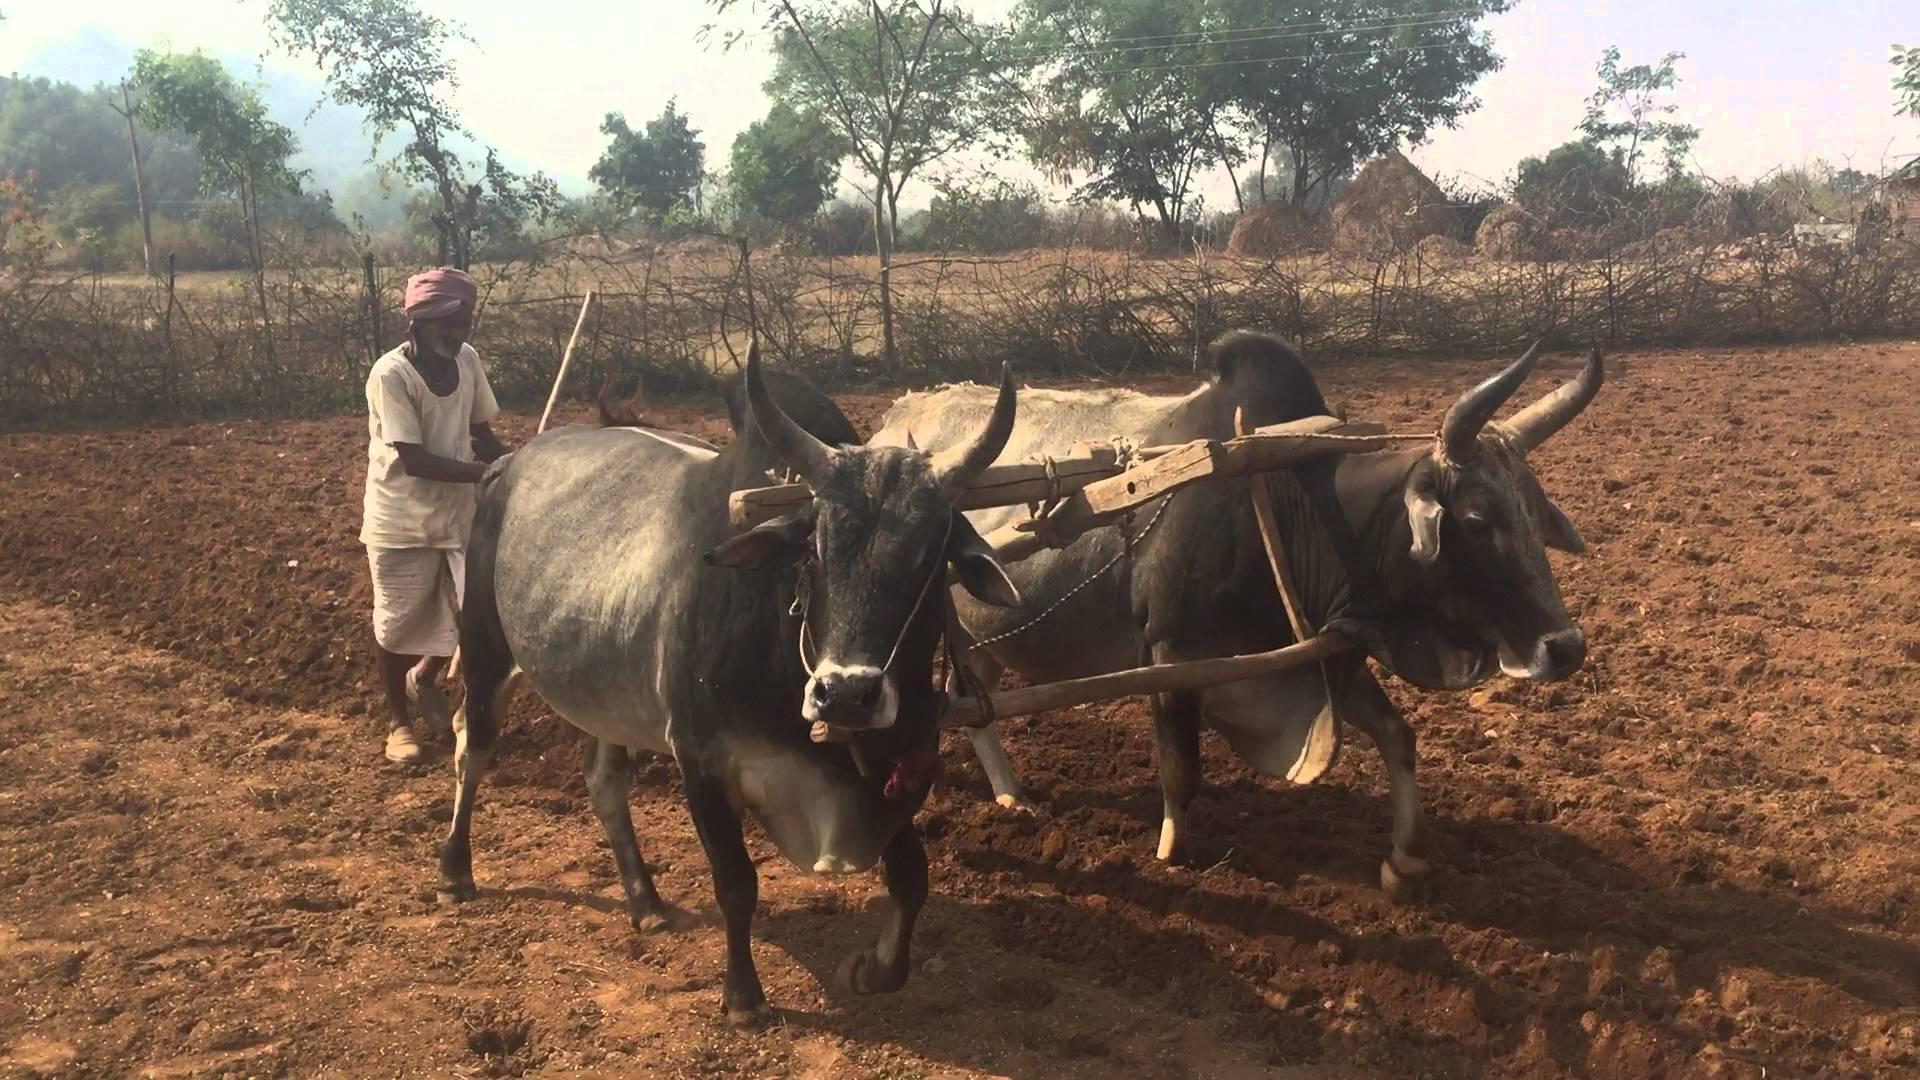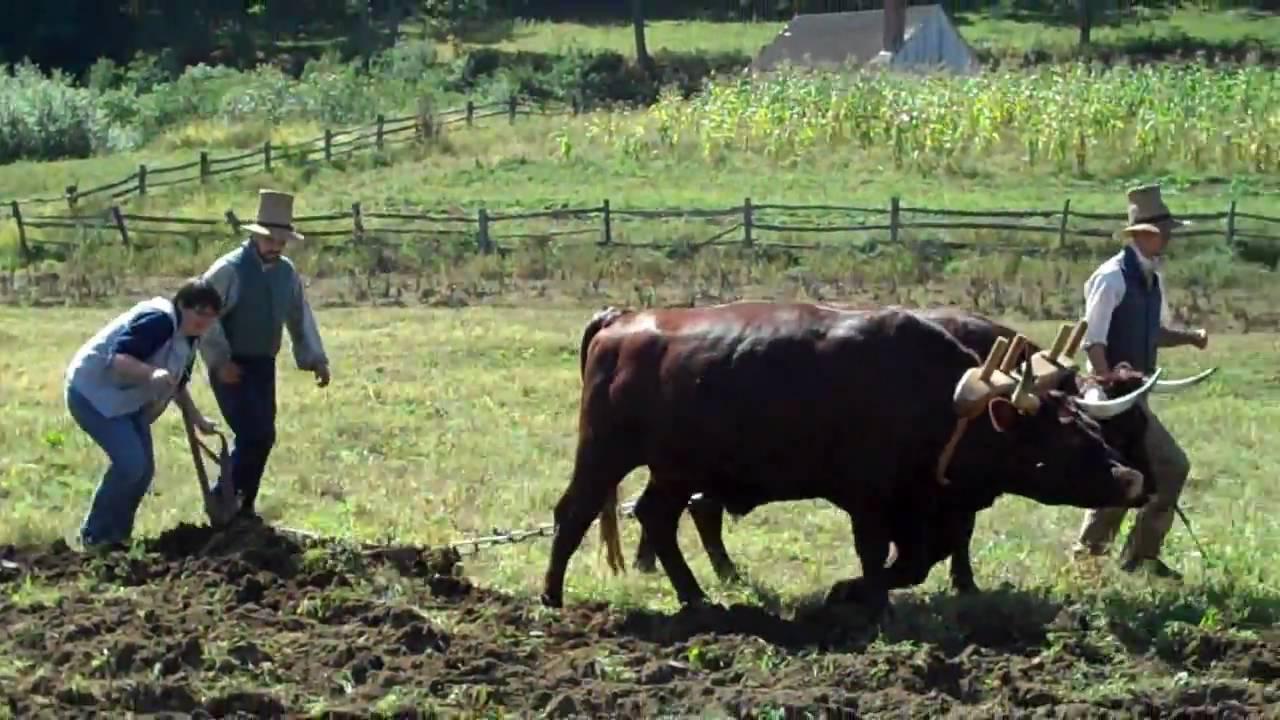The first image is the image on the left, the second image is the image on the right. Examine the images to the left and right. Is the description "In one of the images there are 2 people wearing a hat." accurate? Answer yes or no. Yes. The first image is the image on the left, the second image is the image on the right. Examine the images to the left and right. Is the description "One image includes two spotted oxen pulling a plow, and the other image shows a plow team with at least two solid black oxen." accurate? Answer yes or no. No. 